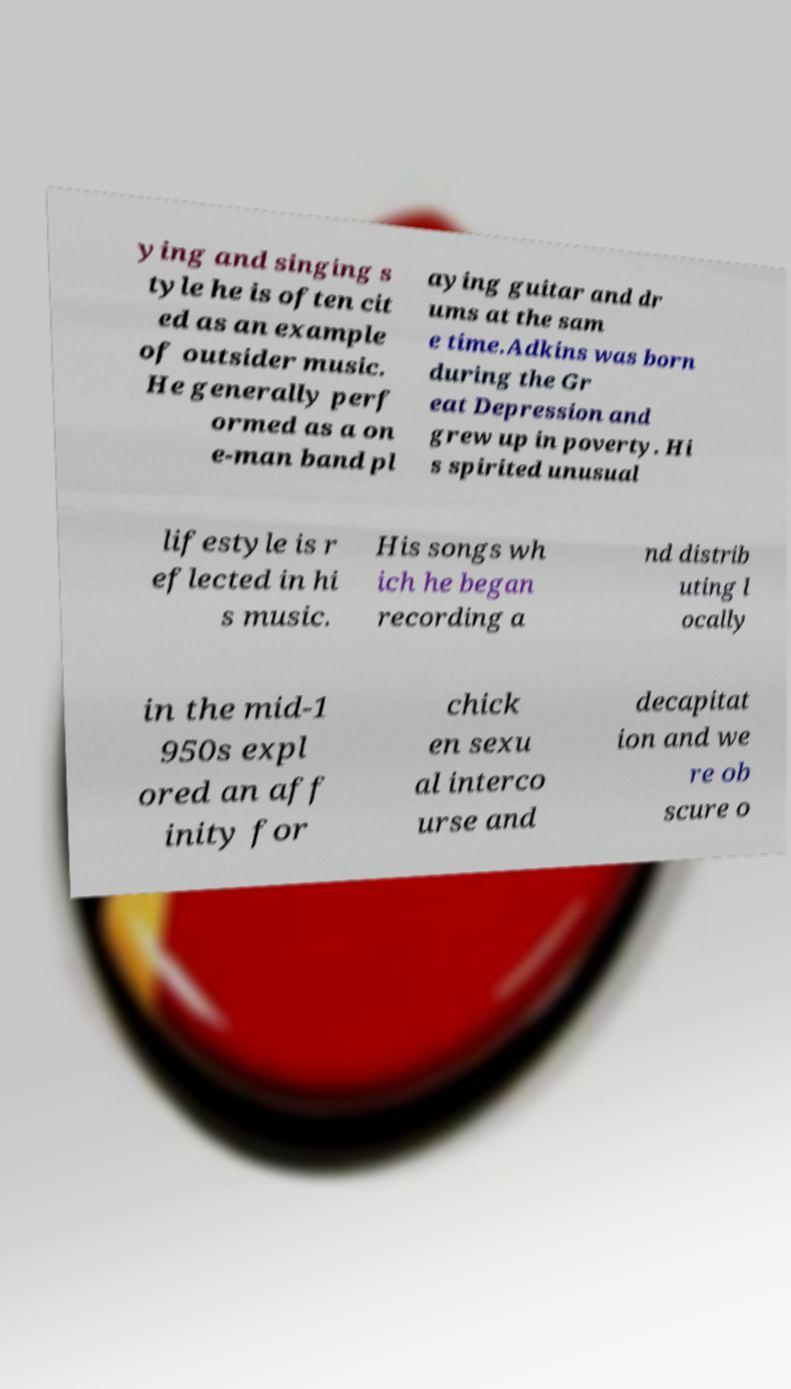Can you read and provide the text displayed in the image?This photo seems to have some interesting text. Can you extract and type it out for me? ying and singing s tyle he is often cit ed as an example of outsider music. He generally perf ormed as a on e-man band pl aying guitar and dr ums at the sam e time.Adkins was born during the Gr eat Depression and grew up in poverty. Hi s spirited unusual lifestyle is r eflected in hi s music. His songs wh ich he began recording a nd distrib uting l ocally in the mid-1 950s expl ored an aff inity for chick en sexu al interco urse and decapitat ion and we re ob scure o 